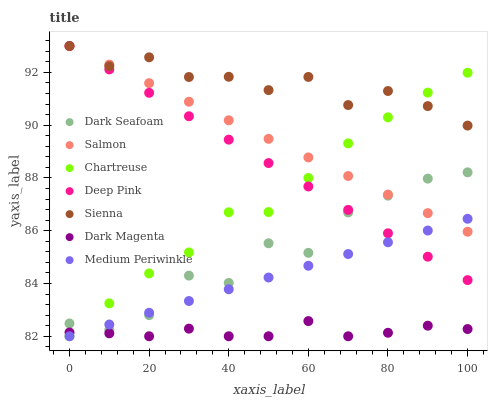Does Dark Magenta have the minimum area under the curve?
Answer yes or no. Yes. Does Sienna have the maximum area under the curve?
Answer yes or no. Yes. Does Medium Periwinkle have the minimum area under the curve?
Answer yes or no. No. Does Medium Periwinkle have the maximum area under the curve?
Answer yes or no. No. Is Salmon the smoothest?
Answer yes or no. Yes. Is Dark Seafoam the roughest?
Answer yes or no. Yes. Is Dark Magenta the smoothest?
Answer yes or no. No. Is Dark Magenta the roughest?
Answer yes or no. No. Does Dark Magenta have the lowest value?
Answer yes or no. Yes. Does Salmon have the lowest value?
Answer yes or no. No. Does Sienna have the highest value?
Answer yes or no. Yes. Does Medium Periwinkle have the highest value?
Answer yes or no. No. Is Dark Seafoam less than Sienna?
Answer yes or no. Yes. Is Dark Seafoam greater than Dark Magenta?
Answer yes or no. Yes. Does Salmon intersect Dark Seafoam?
Answer yes or no. Yes. Is Salmon less than Dark Seafoam?
Answer yes or no. No. Is Salmon greater than Dark Seafoam?
Answer yes or no. No. Does Dark Seafoam intersect Sienna?
Answer yes or no. No. 